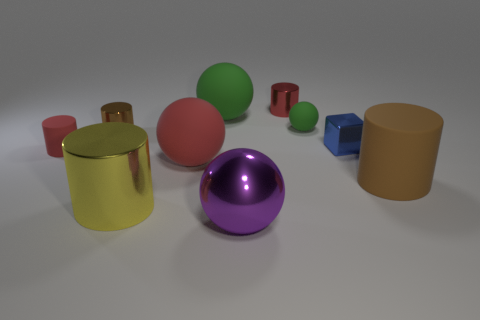How many large red things are on the right side of the object on the right side of the blue metal object?
Keep it short and to the point. 0. What number of other things are there of the same shape as the small red metal thing?
Offer a terse response. 4. What number of things are big gray metallic spheres or large cylinders right of the red metallic cylinder?
Offer a terse response. 1. Are there more big matte balls that are to the left of the small rubber cylinder than purple metallic balls that are behind the small green matte sphere?
Offer a terse response. No. What shape is the rubber object behind the small matte thing that is right of the brown cylinder that is on the left side of the yellow cylinder?
Offer a terse response. Sphere. The red matte object in front of the tiny red cylinder to the left of the red metallic thing is what shape?
Provide a short and direct response. Sphere. Is there a small red block that has the same material as the blue block?
Provide a succinct answer. No. There is another matte sphere that is the same color as the small sphere; what is its size?
Provide a succinct answer. Large. What number of brown things are tiny objects or small shiny things?
Your response must be concise. 1. Is there another cube of the same color as the small block?
Ensure brevity in your answer.  No. 